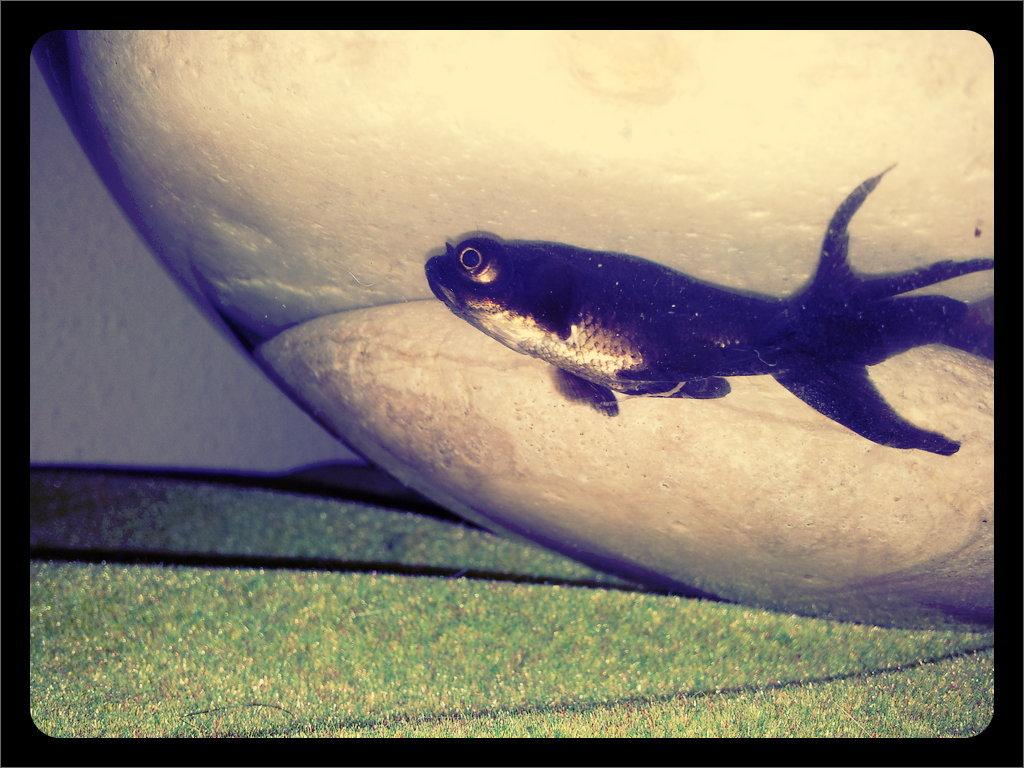What is the shape of the image? The image has borders at the four sides. What is the main subject in the center of the image? There is a fish in the center of the image. What type of knowledge can be gained from the hill in the image? There is no hill present in the image, so no knowledge can be gained from it. 